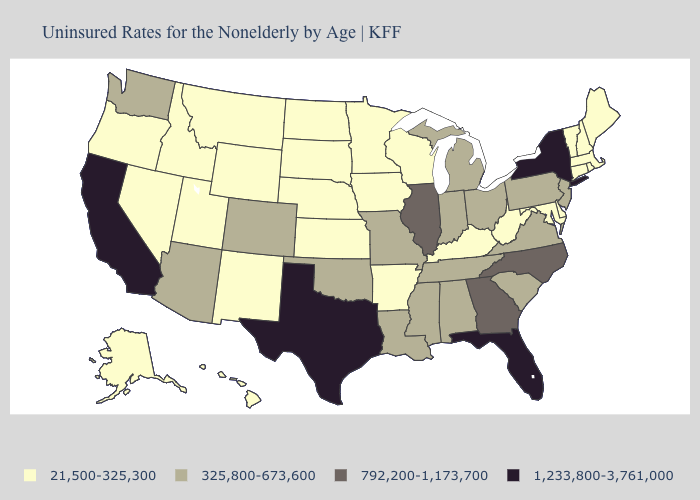Which states have the lowest value in the Northeast?
Short answer required. Connecticut, Maine, Massachusetts, New Hampshire, Rhode Island, Vermont. What is the value of Delaware?
Quick response, please. 21,500-325,300. Name the states that have a value in the range 21,500-325,300?
Be succinct. Alaska, Arkansas, Connecticut, Delaware, Hawaii, Idaho, Iowa, Kansas, Kentucky, Maine, Maryland, Massachusetts, Minnesota, Montana, Nebraska, Nevada, New Hampshire, New Mexico, North Dakota, Oregon, Rhode Island, South Dakota, Utah, Vermont, West Virginia, Wisconsin, Wyoming. Name the states that have a value in the range 325,800-673,600?
Answer briefly. Alabama, Arizona, Colorado, Indiana, Louisiana, Michigan, Mississippi, Missouri, New Jersey, Ohio, Oklahoma, Pennsylvania, South Carolina, Tennessee, Virginia, Washington. Which states hav the highest value in the MidWest?
Write a very short answer. Illinois. Does the map have missing data?
Write a very short answer. No. Among the states that border Maryland , which have the highest value?
Keep it brief. Pennsylvania, Virginia. Does New York have a lower value than Colorado?
Quick response, please. No. Name the states that have a value in the range 21,500-325,300?
Give a very brief answer. Alaska, Arkansas, Connecticut, Delaware, Hawaii, Idaho, Iowa, Kansas, Kentucky, Maine, Maryland, Massachusetts, Minnesota, Montana, Nebraska, Nevada, New Hampshire, New Mexico, North Dakota, Oregon, Rhode Island, South Dakota, Utah, Vermont, West Virginia, Wisconsin, Wyoming. Which states hav the highest value in the MidWest?
Be succinct. Illinois. What is the lowest value in states that border New Jersey?
Concise answer only. 21,500-325,300. What is the value of Illinois?
Keep it brief. 792,200-1,173,700. What is the highest value in the USA?
Quick response, please. 1,233,800-3,761,000. Does Texas have the highest value in the South?
Be succinct. Yes. What is the lowest value in states that border Louisiana?
Be succinct. 21,500-325,300. 